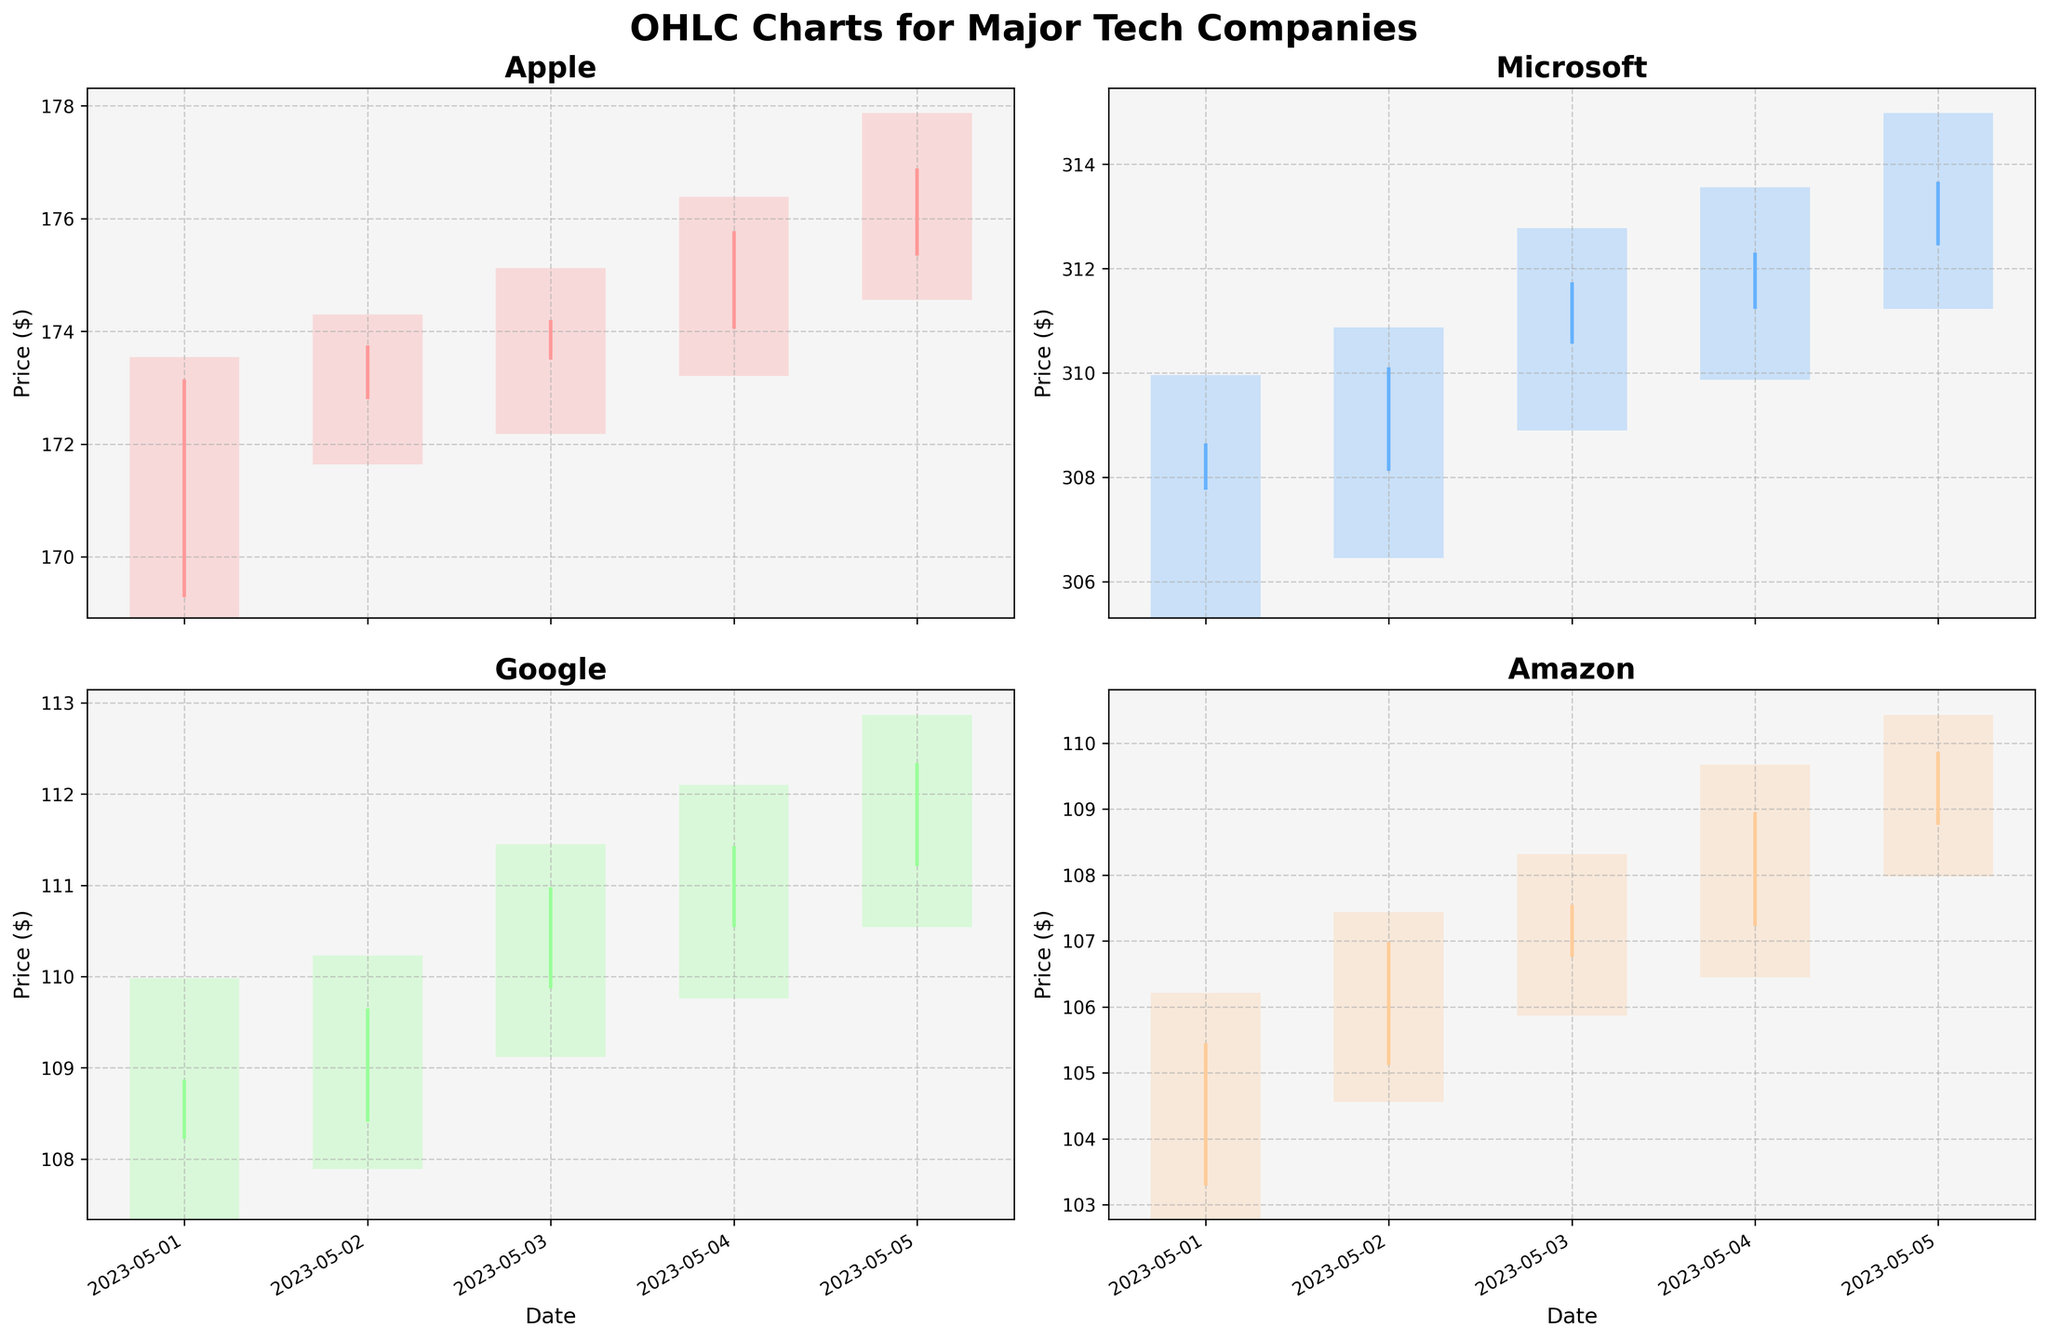Which company showed the highest closing price on May 5th? By examining the closing prices for each company on May 5th within the OHLC charts for all four companies, it's clear that Microsoft had the highest closing price at $313.67
Answer: Microsoft What was the average closing price for Apple over the five days? To find the average closing price for Apple, sum up the closing prices for each day: $173.15, $173.75, $174.20, $175.78, and $176.89. The total is $873.77. Divide this by the number of days (5). So, the average is $873.77 / 5 = $174.75
Answer: $174.75 Did any company's closing price consistently increase each day from May 1st to May 5th? Checking the closing prices daily for each company:
Apple: $173.15, $173.75, $174.20, $175.78, $176.89
Microsoft: $308.65, $310.11, $311.74, $312.31, $313.67
Google: $108.87, $109.65, $110.98, $111.43, $112.34
Amazon: $105.45, $106.98, $107.55, $108.95, $109.87
All four major tech companies show a consistent increase in closing prices each day.
Answer: All four major tech companies What was the largest daily high minus low range for Google within these dates? The daily high minus low ranges for Google:
May 1: $109.98 - $107.34 = $2.64
May 2: $110.23 - $107.89 = $2.34
May 3: $111.45 - $109.12 = $2.33
May 4: $112.10 - $109.76 = $2.34
May 5: $112.87 - $110.54 = $2.33
The largest range is $2.64 on May 1st.
Answer: $2.64 Which company had the highest volatility based on the OHLC charts? Volatility can be evaluated by the range between daily highs and lows. Apple, Microsoft, Google, and Amazon charts all indicate their respective oscillations. Comparing them visually, Amazon and Google show somewhat similar patters with limited swings in their ranges. Apple and Microsoft have more prominent ranges, with Microsoft appearing to show slightly more consistent larger ranges. Thus, Microsoft likely had the highest volatility during these dates.
Answer: Microsoft 